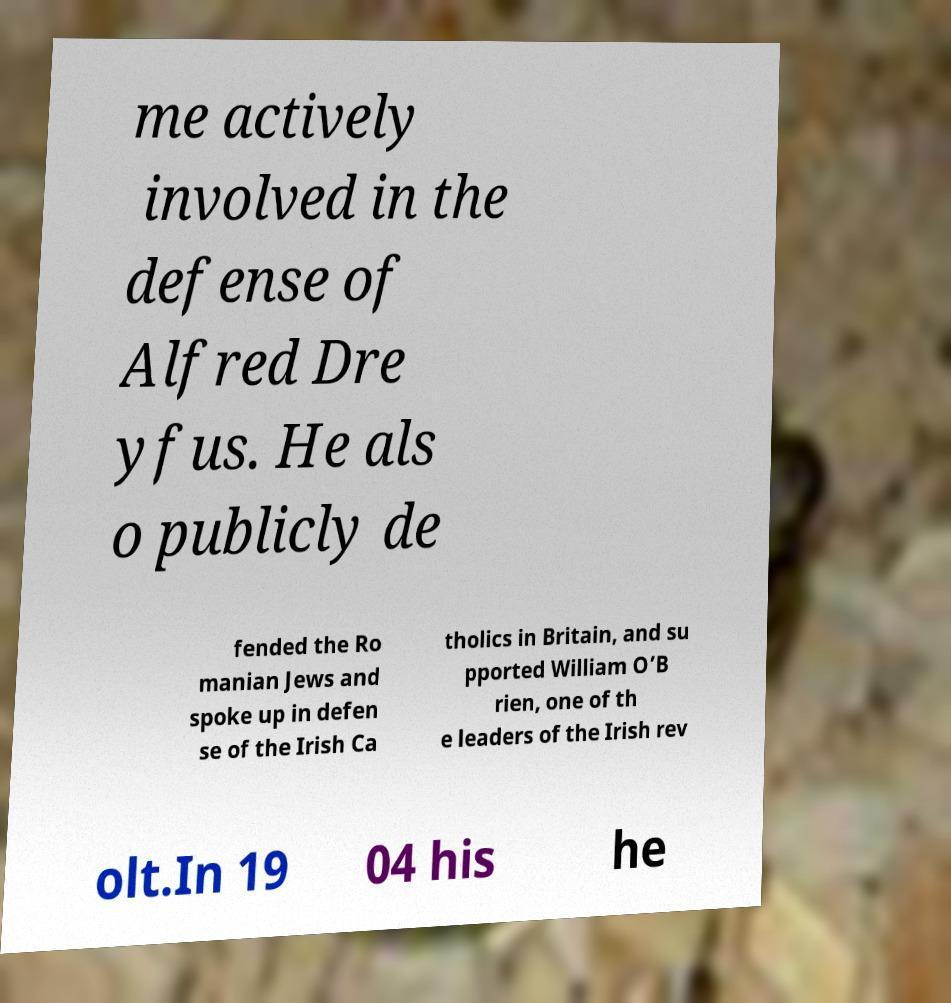There's text embedded in this image that I need extracted. Can you transcribe it verbatim? me actively involved in the defense of Alfred Dre yfus. He als o publicly de fended the Ro manian Jews and spoke up in defen se of the Irish Ca tholics in Britain, and su pported William O’B rien, one of th e leaders of the Irish rev olt.In 19 04 his he 